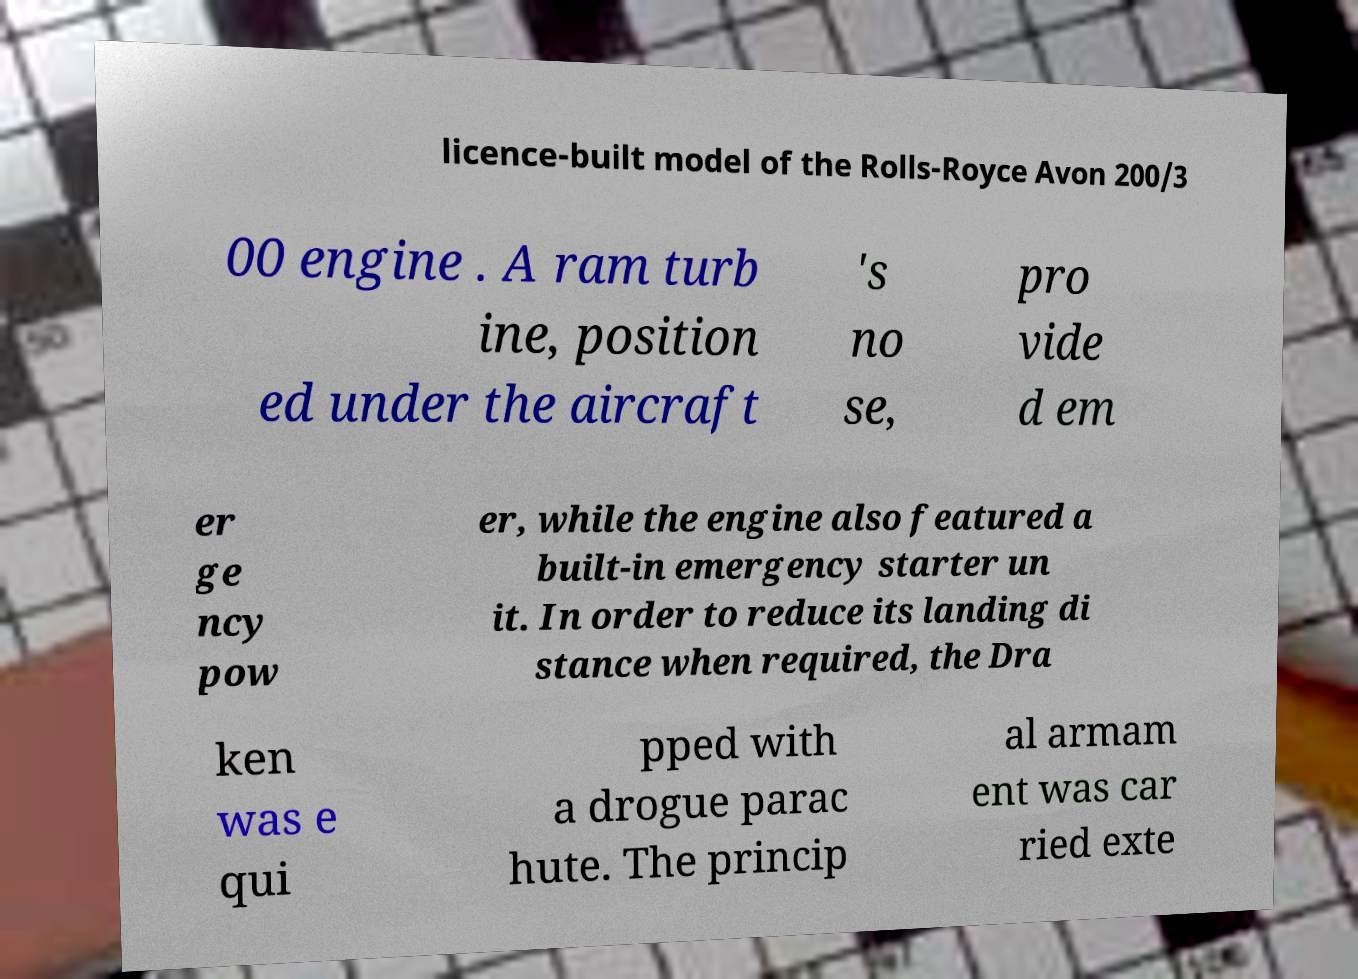There's text embedded in this image that I need extracted. Can you transcribe it verbatim? licence-built model of the Rolls-Royce Avon 200/3 00 engine . A ram turb ine, position ed under the aircraft 's no se, pro vide d em er ge ncy pow er, while the engine also featured a built-in emergency starter un it. In order to reduce its landing di stance when required, the Dra ken was e qui pped with a drogue parac hute. The princip al armam ent was car ried exte 